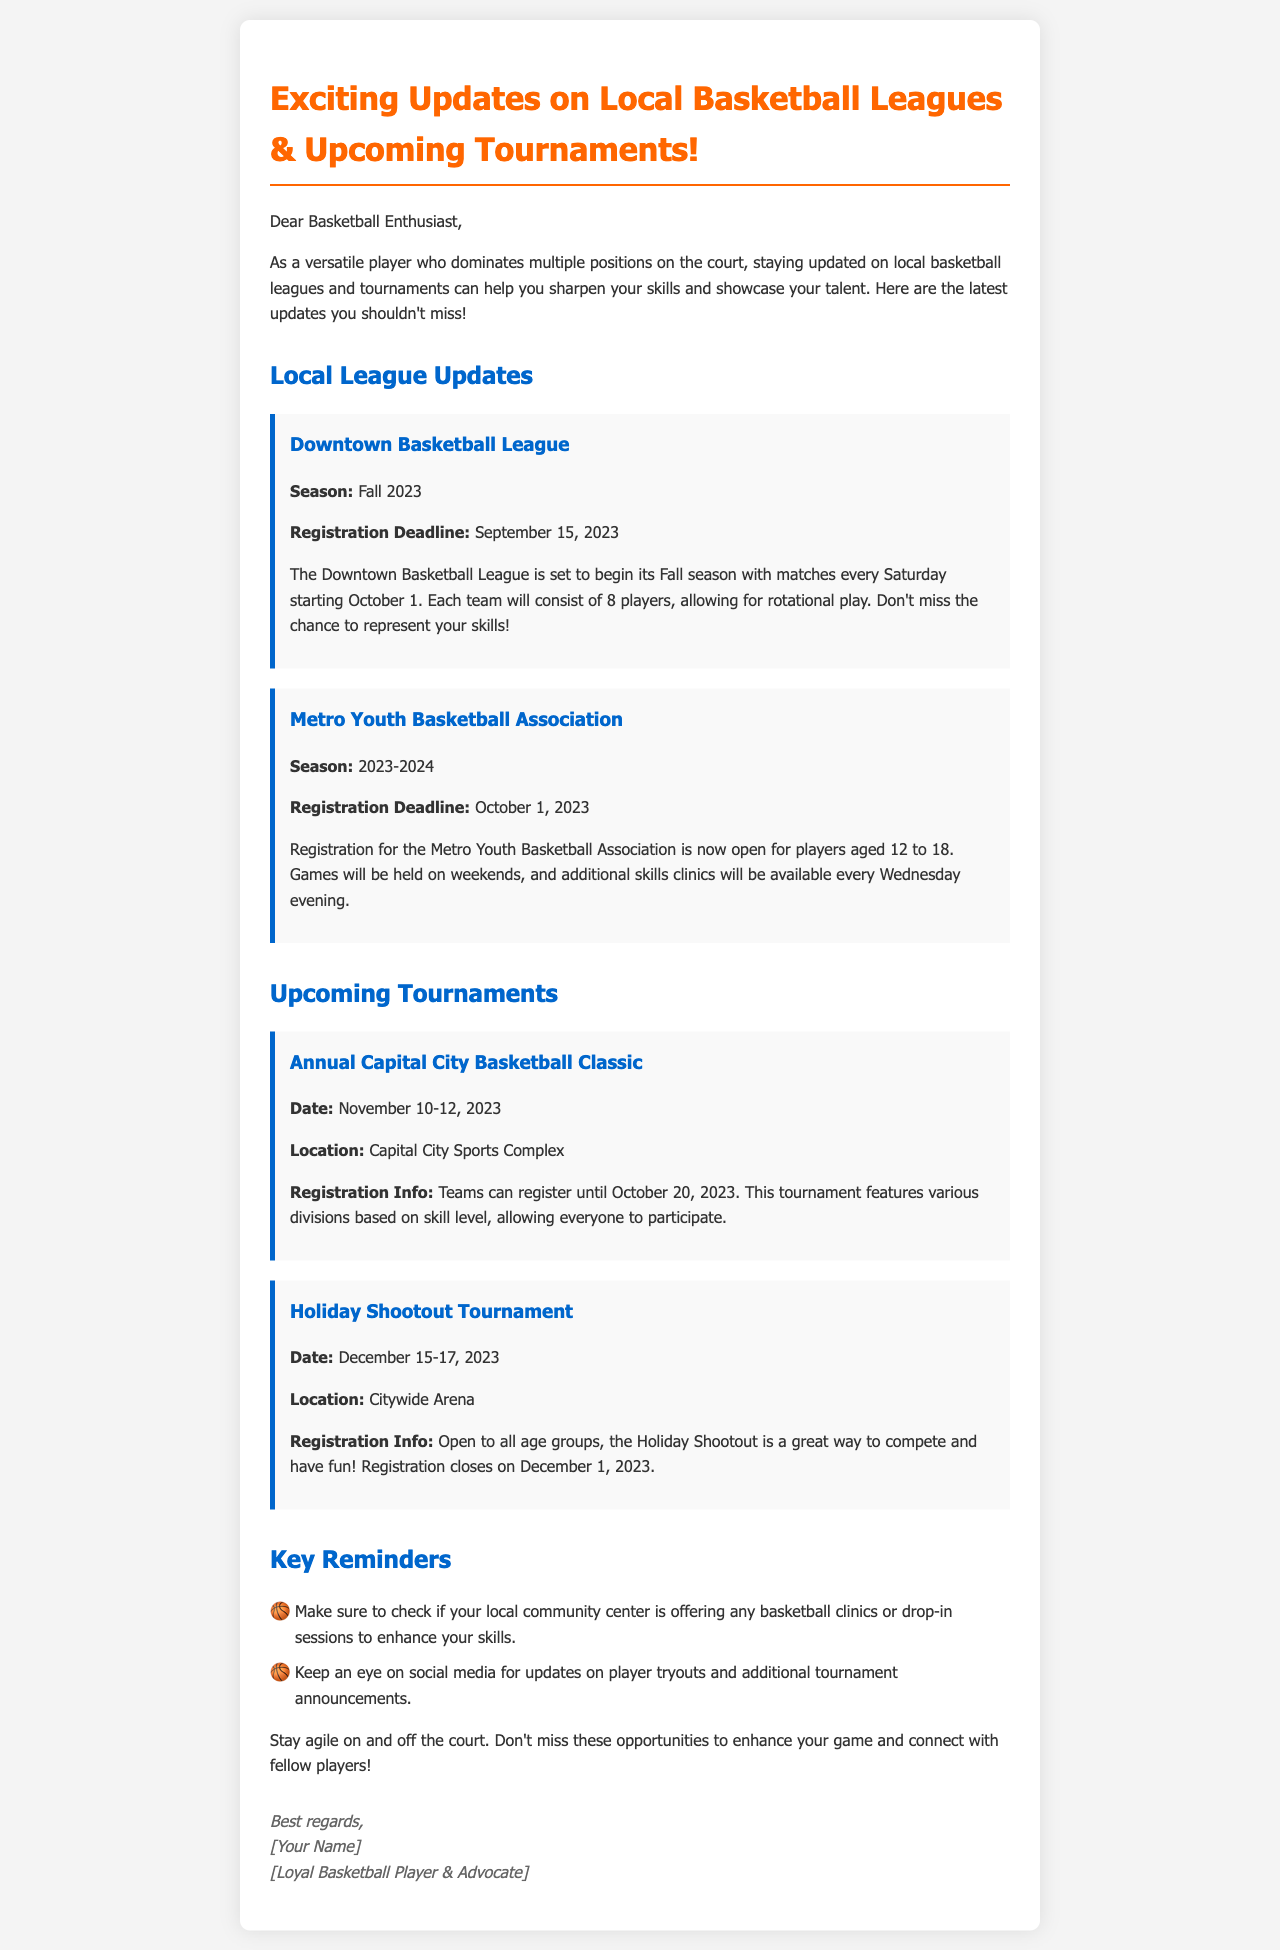What is the registration deadline for the Downtown Basketball League? The registration deadline is specified in the document under the Downtown Basketball League section.
Answer: September 15, 2023 When does the Fall 2023 season for the Downtown Basketball League begin? The document states that the Downtown Basketball League's Fall season starts on October 1.
Answer: October 1 What is the age range for players in the Metro Youth Basketball Association? The age range is provided in the section dedicated to the Metro Youth Basketball Association.
Answer: 12 to 18 What is the location of the Annual Capital City Basketball Classic tournament? The document mentions the location of this tournament in the relevant section.
Answer: Capital City Sports Complex When does registration close for the Holiday Shootout Tournament? The closing date for registration is noted in the Holiday Shootout Tournament section of the document.
Answer: December 1, 2023 What types of basketball events are mentioned for the Metro Youth Basketball Association? The document lists the events related to the Metro Youth Basketball Association, requiring reasoning over the information presented.
Answer: Skills clinics How many players are allowed on each team in the Downtown Basketball League? The document provides specific team information, including the number of players per team.
Answer: 8 players What is one key reminder mentioned in the document? The key reminders section includes multiple pieces of advice, but the question focuses on a single reminder for a concise answer.
Answer: Check local community center clinics Who is the intended audience of the email? The document addresses a specific audience at the beginning, allowing us to infer their identity.
Answer: Basketball Enthusiast 